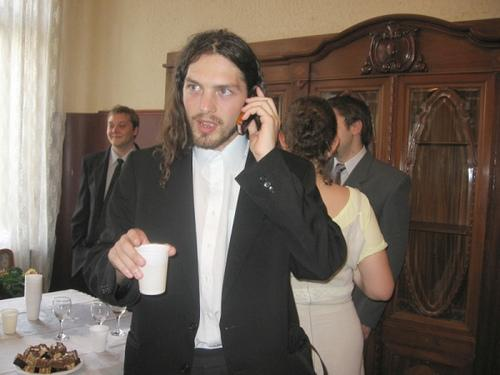What kind of telephone is being used?

Choices:
A) rotary
B) cellular
C) pay
D) landline cellular 